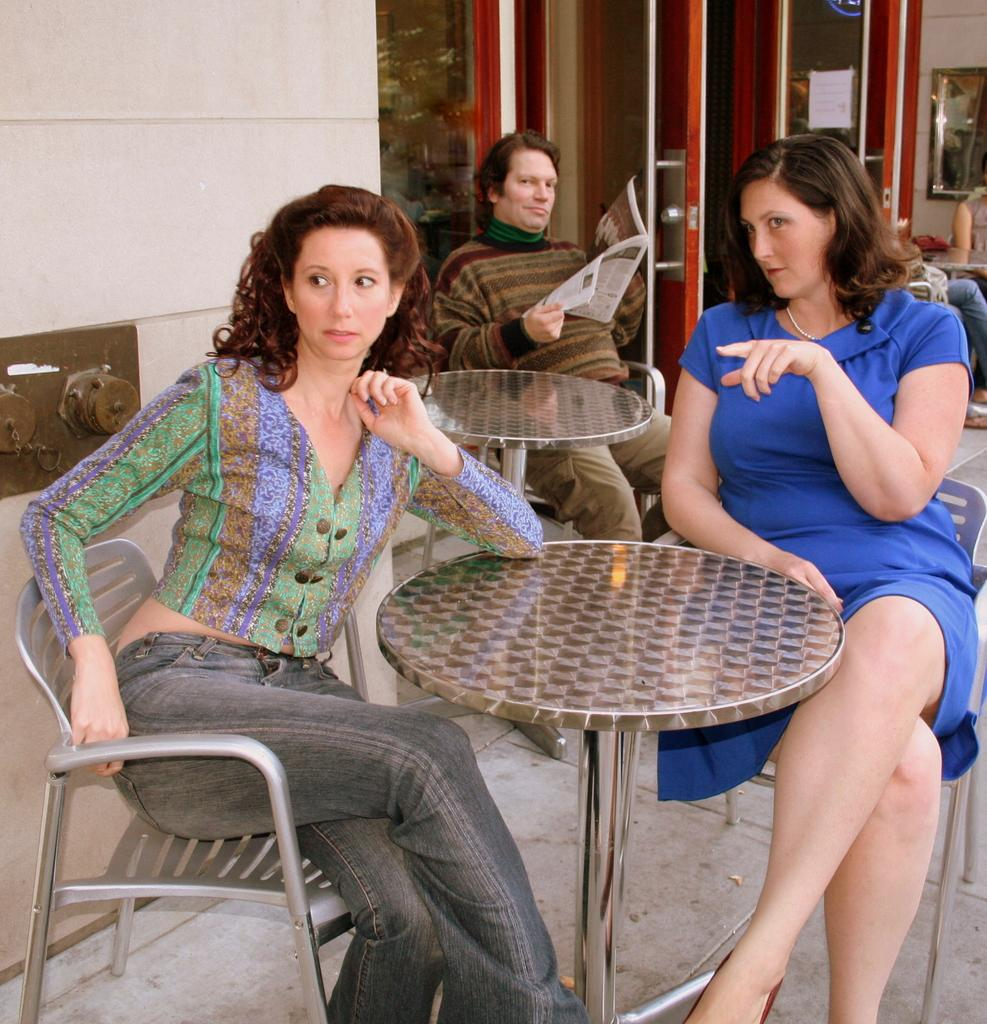How many ladies are sitting in the chairs in the image? There are two ladies sitting in chairs in the image. What is in front of the ladies? There is a table in front of the ladies. Can you describe the person in the background? The person in the background is sitting and holding newspapers in his hands. What color are the stockings worn by the ladies in the image? There is no information about stockings or their color in the provided facts, so we cannot answer this question. --- 